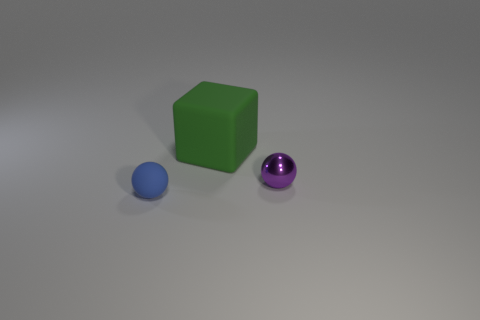Add 1 tiny red metal things. How many objects exist? 4 Subtract all balls. How many objects are left? 1 Subtract 1 balls. How many balls are left? 1 Subtract all gray balls. Subtract all cyan blocks. How many balls are left? 2 Add 1 large rubber cubes. How many large rubber cubes are left? 2 Add 1 metal cylinders. How many metal cylinders exist? 1 Subtract 0 brown spheres. How many objects are left? 3 Subtract all red shiny cylinders. Subtract all big objects. How many objects are left? 2 